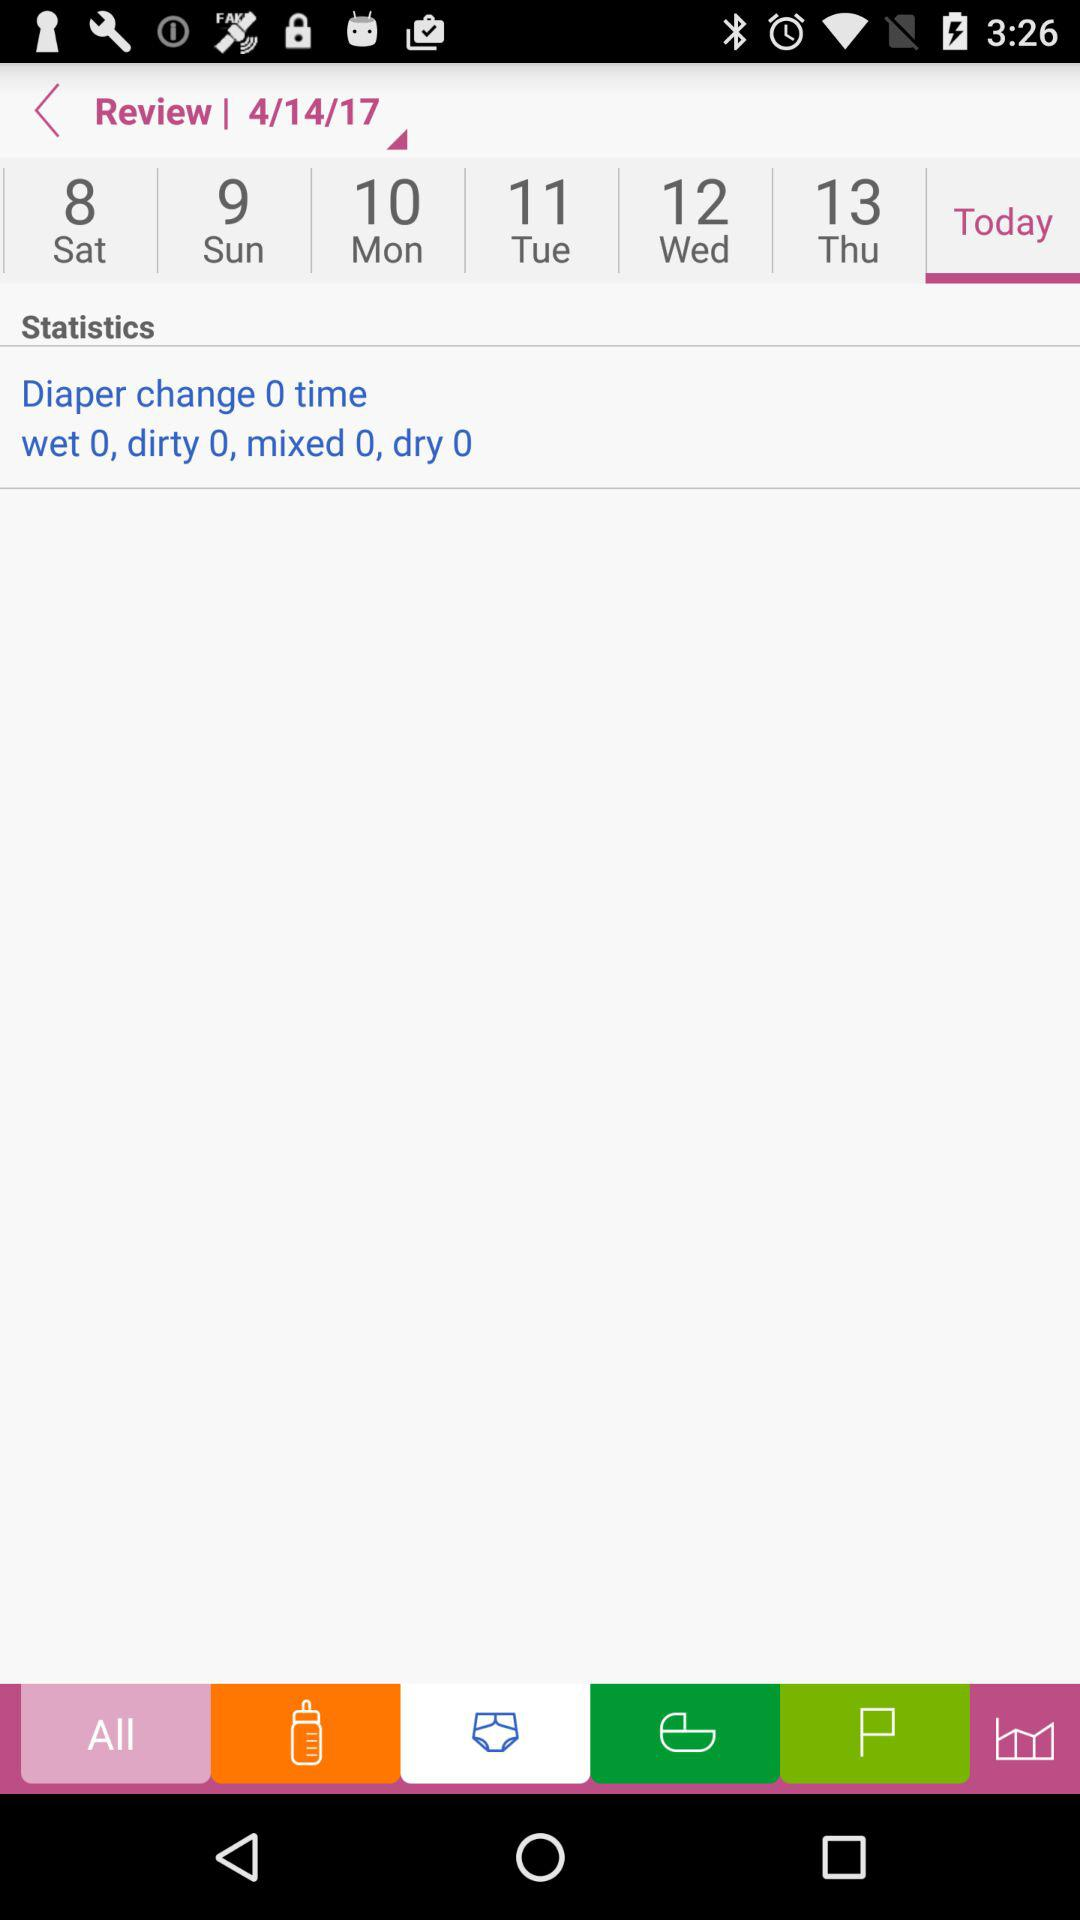How many times has the diaper been changed?
Answer the question using a single word or phrase. 0 